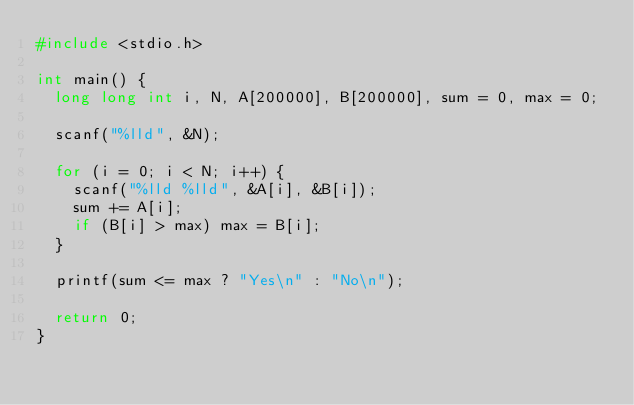Convert code to text. <code><loc_0><loc_0><loc_500><loc_500><_C_>#include <stdio.h>

int main() {
	long long int i, N, A[200000], B[200000], sum = 0, max = 0;

	scanf("%lld", &N);

	for (i = 0; i < N; i++) {
		scanf("%lld %lld", &A[i], &B[i]);
		sum += A[i];
		if (B[i] > max) max = B[i];
	}

	printf(sum <= max ? "Yes\n" : "No\n");

	return 0;
}</code> 